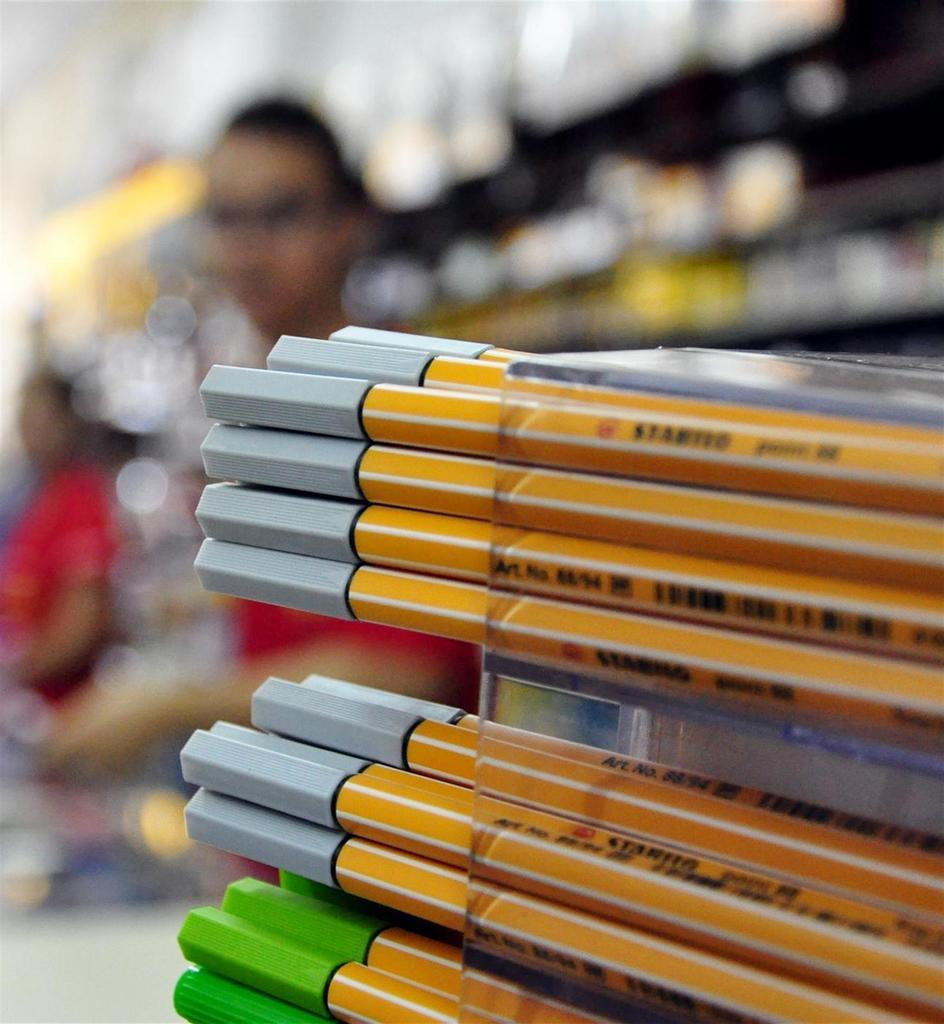What objects are in the image? There are pencils in the image. Where are the pencils located? The pencils are in a rack. How many people can be seen in the image? There are at least two persons standing in the image. What type of frog can be seen in the image? There is no frog present in the image. Is the alley visible in the image? The provided facts do not mention an alley, so it cannot be determined if it is visible in the image. 